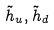Convert formula to latex. <formula><loc_0><loc_0><loc_500><loc_500>\tilde { h } _ { u } , \tilde { h } _ { d }</formula> 